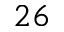<formula> <loc_0><loc_0><loc_500><loc_500>2 6</formula> 